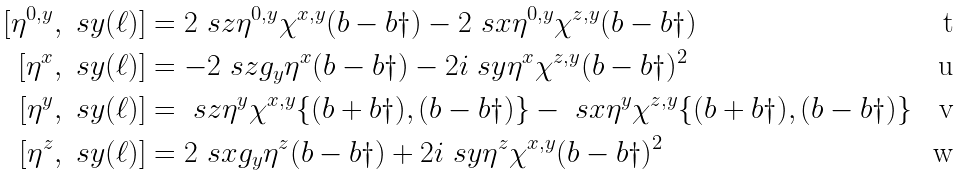<formula> <loc_0><loc_0><loc_500><loc_500>[ \eta ^ { 0 , y } , \ s y ( \ell ) ] & = 2 \ s z \eta ^ { 0 , y } \chi ^ { x , y } ( b - b \dag ) - 2 \ s x \eta ^ { 0 , y } \chi ^ { z , y } ( b - b \dag ) \\ [ \eta ^ { x } , \ s y ( \ell ) ] & = - 2 \ s z g _ { y } \eta ^ { x } ( b - b \dag ) - 2 i \ s y \eta ^ { x } \chi ^ { z , y } ( b - b \dag ) ^ { 2 } \\ [ \eta ^ { y } , \ s y ( \ell ) ] & = \ s z \eta ^ { y } \chi ^ { x , y } \{ ( b + b \dag ) , ( b - b \dag ) \} - \ s x \eta ^ { y } \chi ^ { z , y } \{ ( b + b \dag ) , ( b - b \dag ) \} \\ [ \eta ^ { z } , \ s y ( \ell ) ] & = 2 \ s x g _ { y } \eta ^ { z } ( b - b \dag ) + 2 i \ s y \eta ^ { z } \chi ^ { x , y } ( b - b \dag ) ^ { 2 }</formula> 